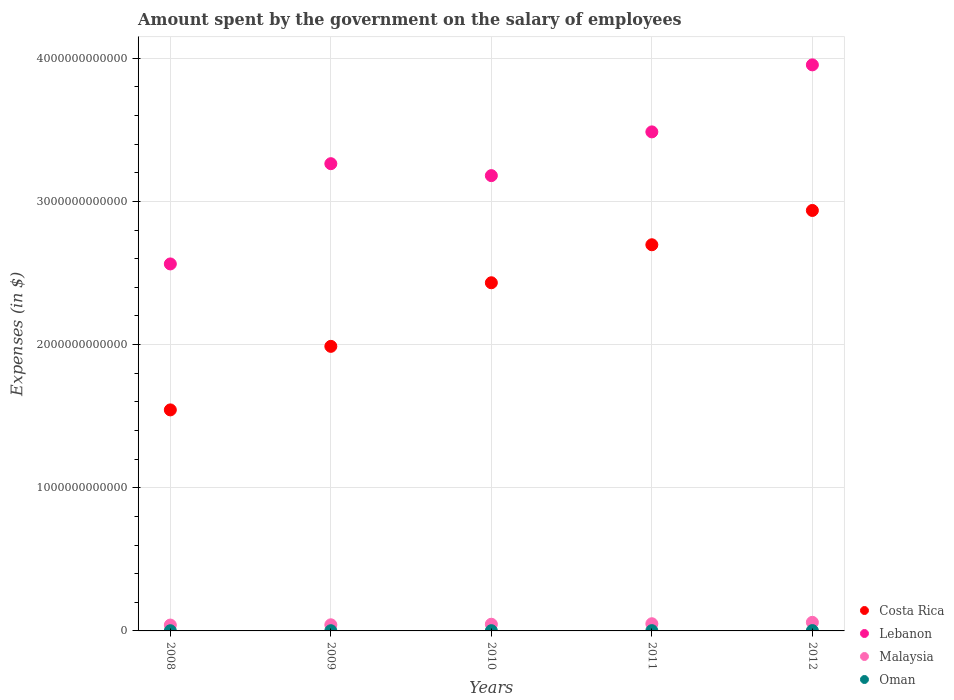How many different coloured dotlines are there?
Provide a succinct answer. 4. Is the number of dotlines equal to the number of legend labels?
Offer a terse response. Yes. What is the amount spent on the salary of employees by the government in Oman in 2009?
Offer a terse response. 1.51e+09. Across all years, what is the maximum amount spent on the salary of employees by the government in Costa Rica?
Give a very brief answer. 2.94e+12. Across all years, what is the minimum amount spent on the salary of employees by the government in Costa Rica?
Keep it short and to the point. 1.54e+12. What is the total amount spent on the salary of employees by the government in Costa Rica in the graph?
Give a very brief answer. 1.16e+13. What is the difference between the amount spent on the salary of employees by the government in Malaysia in 2008 and that in 2012?
Offer a terse response. -1.90e+1. What is the difference between the amount spent on the salary of employees by the government in Malaysia in 2008 and the amount spent on the salary of employees by the government in Oman in 2012?
Your answer should be compact. 3.87e+1. What is the average amount spent on the salary of employees by the government in Costa Rica per year?
Your answer should be compact. 2.32e+12. In the year 2010, what is the difference between the amount spent on the salary of employees by the government in Costa Rica and amount spent on the salary of employees by the government in Oman?
Ensure brevity in your answer.  2.43e+12. In how many years, is the amount spent on the salary of employees by the government in Lebanon greater than 1600000000000 $?
Ensure brevity in your answer.  5. What is the ratio of the amount spent on the salary of employees by the government in Oman in 2009 to that in 2010?
Provide a succinct answer. 0.87. What is the difference between the highest and the second highest amount spent on the salary of employees by the government in Malaysia?
Make the answer very short. 9.87e+09. What is the difference between the highest and the lowest amount spent on the salary of employees by the government in Costa Rica?
Your response must be concise. 1.39e+12. Is the sum of the amount spent on the salary of employees by the government in Malaysia in 2011 and 2012 greater than the maximum amount spent on the salary of employees by the government in Oman across all years?
Ensure brevity in your answer.  Yes. Is it the case that in every year, the sum of the amount spent on the salary of employees by the government in Oman and amount spent on the salary of employees by the government in Lebanon  is greater than the sum of amount spent on the salary of employees by the government in Costa Rica and amount spent on the salary of employees by the government in Malaysia?
Provide a succinct answer. Yes. Does the amount spent on the salary of employees by the government in Lebanon monotonically increase over the years?
Offer a terse response. No. Is the amount spent on the salary of employees by the government in Lebanon strictly greater than the amount spent on the salary of employees by the government in Costa Rica over the years?
Offer a very short reply. Yes. Is the amount spent on the salary of employees by the government in Costa Rica strictly less than the amount spent on the salary of employees by the government in Malaysia over the years?
Give a very brief answer. No. How many dotlines are there?
Your answer should be compact. 4. How many years are there in the graph?
Ensure brevity in your answer.  5. What is the difference between two consecutive major ticks on the Y-axis?
Your answer should be very brief. 1.00e+12. Does the graph contain grids?
Offer a very short reply. Yes. Where does the legend appear in the graph?
Your response must be concise. Bottom right. How many legend labels are there?
Provide a short and direct response. 4. How are the legend labels stacked?
Provide a succinct answer. Vertical. What is the title of the graph?
Offer a very short reply. Amount spent by the government on the salary of employees. Does "Tunisia" appear as one of the legend labels in the graph?
Provide a succinct answer. No. What is the label or title of the X-axis?
Give a very brief answer. Years. What is the label or title of the Y-axis?
Keep it short and to the point. Expenses (in $). What is the Expenses (in $) of Costa Rica in 2008?
Offer a terse response. 1.54e+12. What is the Expenses (in $) of Lebanon in 2008?
Offer a very short reply. 2.56e+12. What is the Expenses (in $) in Malaysia in 2008?
Your response must be concise. 4.10e+1. What is the Expenses (in $) in Oman in 2008?
Provide a succinct answer. 1.37e+09. What is the Expenses (in $) in Costa Rica in 2009?
Your answer should be compact. 1.99e+12. What is the Expenses (in $) of Lebanon in 2009?
Keep it short and to the point. 3.26e+12. What is the Expenses (in $) in Malaysia in 2009?
Your answer should be very brief. 4.28e+1. What is the Expenses (in $) in Oman in 2009?
Keep it short and to the point. 1.51e+09. What is the Expenses (in $) of Costa Rica in 2010?
Make the answer very short. 2.43e+12. What is the Expenses (in $) of Lebanon in 2010?
Ensure brevity in your answer.  3.18e+12. What is the Expenses (in $) of Malaysia in 2010?
Ensure brevity in your answer.  4.67e+1. What is the Expenses (in $) in Oman in 2010?
Ensure brevity in your answer.  1.72e+09. What is the Expenses (in $) of Costa Rica in 2011?
Provide a succinct answer. 2.70e+12. What is the Expenses (in $) of Lebanon in 2011?
Give a very brief answer. 3.49e+12. What is the Expenses (in $) of Malaysia in 2011?
Give a very brief answer. 5.01e+1. What is the Expenses (in $) in Oman in 2011?
Offer a very short reply. 1.94e+09. What is the Expenses (in $) in Costa Rica in 2012?
Provide a succinct answer. 2.94e+12. What is the Expenses (in $) of Lebanon in 2012?
Make the answer very short. 3.95e+12. What is the Expenses (in $) in Malaysia in 2012?
Your response must be concise. 6.00e+1. What is the Expenses (in $) of Oman in 2012?
Offer a very short reply. 2.31e+09. Across all years, what is the maximum Expenses (in $) of Costa Rica?
Give a very brief answer. 2.94e+12. Across all years, what is the maximum Expenses (in $) of Lebanon?
Offer a very short reply. 3.95e+12. Across all years, what is the maximum Expenses (in $) of Malaysia?
Provide a short and direct response. 6.00e+1. Across all years, what is the maximum Expenses (in $) of Oman?
Your answer should be compact. 2.31e+09. Across all years, what is the minimum Expenses (in $) of Costa Rica?
Provide a succinct answer. 1.54e+12. Across all years, what is the minimum Expenses (in $) of Lebanon?
Offer a terse response. 2.56e+12. Across all years, what is the minimum Expenses (in $) in Malaysia?
Your answer should be compact. 4.10e+1. Across all years, what is the minimum Expenses (in $) of Oman?
Your response must be concise. 1.37e+09. What is the total Expenses (in $) of Costa Rica in the graph?
Offer a terse response. 1.16e+13. What is the total Expenses (in $) in Lebanon in the graph?
Keep it short and to the point. 1.64e+13. What is the total Expenses (in $) of Malaysia in the graph?
Provide a succinct answer. 2.41e+11. What is the total Expenses (in $) of Oman in the graph?
Keep it short and to the point. 8.84e+09. What is the difference between the Expenses (in $) in Costa Rica in 2008 and that in 2009?
Your answer should be very brief. -4.44e+11. What is the difference between the Expenses (in $) of Lebanon in 2008 and that in 2009?
Your answer should be compact. -7.00e+11. What is the difference between the Expenses (in $) of Malaysia in 2008 and that in 2009?
Your answer should be very brief. -1.77e+09. What is the difference between the Expenses (in $) in Oman in 2008 and that in 2009?
Offer a terse response. -1.37e+08. What is the difference between the Expenses (in $) of Costa Rica in 2008 and that in 2010?
Offer a very short reply. -8.88e+11. What is the difference between the Expenses (in $) of Lebanon in 2008 and that in 2010?
Offer a terse response. -6.17e+11. What is the difference between the Expenses (in $) of Malaysia in 2008 and that in 2010?
Give a very brief answer. -5.65e+09. What is the difference between the Expenses (in $) in Oman in 2008 and that in 2010?
Make the answer very short. -3.54e+08. What is the difference between the Expenses (in $) in Costa Rica in 2008 and that in 2011?
Offer a terse response. -1.15e+12. What is the difference between the Expenses (in $) of Lebanon in 2008 and that in 2011?
Provide a short and direct response. -9.22e+11. What is the difference between the Expenses (in $) in Malaysia in 2008 and that in 2011?
Ensure brevity in your answer.  -9.14e+09. What is the difference between the Expenses (in $) of Oman in 2008 and that in 2011?
Provide a succinct answer. -5.66e+08. What is the difference between the Expenses (in $) in Costa Rica in 2008 and that in 2012?
Provide a succinct answer. -1.39e+12. What is the difference between the Expenses (in $) in Lebanon in 2008 and that in 2012?
Offer a terse response. -1.39e+12. What is the difference between the Expenses (in $) in Malaysia in 2008 and that in 2012?
Provide a short and direct response. -1.90e+1. What is the difference between the Expenses (in $) of Oman in 2008 and that in 2012?
Your answer should be compact. -9.38e+08. What is the difference between the Expenses (in $) of Costa Rica in 2009 and that in 2010?
Keep it short and to the point. -4.44e+11. What is the difference between the Expenses (in $) of Lebanon in 2009 and that in 2010?
Provide a short and direct response. 8.34e+1. What is the difference between the Expenses (in $) of Malaysia in 2009 and that in 2010?
Ensure brevity in your answer.  -3.88e+09. What is the difference between the Expenses (in $) in Oman in 2009 and that in 2010?
Give a very brief answer. -2.16e+08. What is the difference between the Expenses (in $) of Costa Rica in 2009 and that in 2011?
Offer a terse response. -7.10e+11. What is the difference between the Expenses (in $) of Lebanon in 2009 and that in 2011?
Keep it short and to the point. -2.22e+11. What is the difference between the Expenses (in $) of Malaysia in 2009 and that in 2011?
Your response must be concise. -7.37e+09. What is the difference between the Expenses (in $) in Oman in 2009 and that in 2011?
Offer a terse response. -4.29e+08. What is the difference between the Expenses (in $) in Costa Rica in 2009 and that in 2012?
Give a very brief answer. -9.49e+11. What is the difference between the Expenses (in $) in Lebanon in 2009 and that in 2012?
Provide a succinct answer. -6.90e+11. What is the difference between the Expenses (in $) in Malaysia in 2009 and that in 2012?
Offer a terse response. -1.72e+1. What is the difference between the Expenses (in $) of Oman in 2009 and that in 2012?
Make the answer very short. -8.01e+08. What is the difference between the Expenses (in $) of Costa Rica in 2010 and that in 2011?
Provide a succinct answer. -2.65e+11. What is the difference between the Expenses (in $) of Lebanon in 2010 and that in 2011?
Give a very brief answer. -3.06e+11. What is the difference between the Expenses (in $) of Malaysia in 2010 and that in 2011?
Your answer should be compact. -3.49e+09. What is the difference between the Expenses (in $) in Oman in 2010 and that in 2011?
Make the answer very short. -2.13e+08. What is the difference between the Expenses (in $) of Costa Rica in 2010 and that in 2012?
Offer a terse response. -5.05e+11. What is the difference between the Expenses (in $) in Lebanon in 2010 and that in 2012?
Provide a succinct answer. -7.74e+11. What is the difference between the Expenses (in $) of Malaysia in 2010 and that in 2012?
Your answer should be very brief. -1.34e+1. What is the difference between the Expenses (in $) in Oman in 2010 and that in 2012?
Offer a terse response. -5.85e+08. What is the difference between the Expenses (in $) in Costa Rica in 2011 and that in 2012?
Keep it short and to the point. -2.40e+11. What is the difference between the Expenses (in $) of Lebanon in 2011 and that in 2012?
Make the answer very short. -4.68e+11. What is the difference between the Expenses (in $) of Malaysia in 2011 and that in 2012?
Make the answer very short. -9.87e+09. What is the difference between the Expenses (in $) of Oman in 2011 and that in 2012?
Keep it short and to the point. -3.72e+08. What is the difference between the Expenses (in $) of Costa Rica in 2008 and the Expenses (in $) of Lebanon in 2009?
Offer a terse response. -1.72e+12. What is the difference between the Expenses (in $) in Costa Rica in 2008 and the Expenses (in $) in Malaysia in 2009?
Provide a succinct answer. 1.50e+12. What is the difference between the Expenses (in $) in Costa Rica in 2008 and the Expenses (in $) in Oman in 2009?
Offer a very short reply. 1.54e+12. What is the difference between the Expenses (in $) of Lebanon in 2008 and the Expenses (in $) of Malaysia in 2009?
Your response must be concise. 2.52e+12. What is the difference between the Expenses (in $) in Lebanon in 2008 and the Expenses (in $) in Oman in 2009?
Give a very brief answer. 2.56e+12. What is the difference between the Expenses (in $) of Malaysia in 2008 and the Expenses (in $) of Oman in 2009?
Provide a succinct answer. 3.95e+1. What is the difference between the Expenses (in $) of Costa Rica in 2008 and the Expenses (in $) of Lebanon in 2010?
Your answer should be compact. -1.64e+12. What is the difference between the Expenses (in $) of Costa Rica in 2008 and the Expenses (in $) of Malaysia in 2010?
Keep it short and to the point. 1.50e+12. What is the difference between the Expenses (in $) of Costa Rica in 2008 and the Expenses (in $) of Oman in 2010?
Offer a very short reply. 1.54e+12. What is the difference between the Expenses (in $) in Lebanon in 2008 and the Expenses (in $) in Malaysia in 2010?
Give a very brief answer. 2.52e+12. What is the difference between the Expenses (in $) in Lebanon in 2008 and the Expenses (in $) in Oman in 2010?
Keep it short and to the point. 2.56e+12. What is the difference between the Expenses (in $) in Malaysia in 2008 and the Expenses (in $) in Oman in 2010?
Make the answer very short. 3.93e+1. What is the difference between the Expenses (in $) in Costa Rica in 2008 and the Expenses (in $) in Lebanon in 2011?
Give a very brief answer. -1.94e+12. What is the difference between the Expenses (in $) in Costa Rica in 2008 and the Expenses (in $) in Malaysia in 2011?
Provide a succinct answer. 1.49e+12. What is the difference between the Expenses (in $) in Costa Rica in 2008 and the Expenses (in $) in Oman in 2011?
Offer a very short reply. 1.54e+12. What is the difference between the Expenses (in $) in Lebanon in 2008 and the Expenses (in $) in Malaysia in 2011?
Offer a terse response. 2.51e+12. What is the difference between the Expenses (in $) in Lebanon in 2008 and the Expenses (in $) in Oman in 2011?
Your answer should be compact. 2.56e+12. What is the difference between the Expenses (in $) in Malaysia in 2008 and the Expenses (in $) in Oman in 2011?
Provide a succinct answer. 3.91e+1. What is the difference between the Expenses (in $) in Costa Rica in 2008 and the Expenses (in $) in Lebanon in 2012?
Your answer should be very brief. -2.41e+12. What is the difference between the Expenses (in $) in Costa Rica in 2008 and the Expenses (in $) in Malaysia in 2012?
Your response must be concise. 1.48e+12. What is the difference between the Expenses (in $) in Costa Rica in 2008 and the Expenses (in $) in Oman in 2012?
Make the answer very short. 1.54e+12. What is the difference between the Expenses (in $) of Lebanon in 2008 and the Expenses (in $) of Malaysia in 2012?
Make the answer very short. 2.50e+12. What is the difference between the Expenses (in $) of Lebanon in 2008 and the Expenses (in $) of Oman in 2012?
Offer a very short reply. 2.56e+12. What is the difference between the Expenses (in $) in Malaysia in 2008 and the Expenses (in $) in Oman in 2012?
Your answer should be compact. 3.87e+1. What is the difference between the Expenses (in $) in Costa Rica in 2009 and the Expenses (in $) in Lebanon in 2010?
Offer a terse response. -1.19e+12. What is the difference between the Expenses (in $) in Costa Rica in 2009 and the Expenses (in $) in Malaysia in 2010?
Your response must be concise. 1.94e+12. What is the difference between the Expenses (in $) in Costa Rica in 2009 and the Expenses (in $) in Oman in 2010?
Your response must be concise. 1.99e+12. What is the difference between the Expenses (in $) in Lebanon in 2009 and the Expenses (in $) in Malaysia in 2010?
Offer a very short reply. 3.22e+12. What is the difference between the Expenses (in $) in Lebanon in 2009 and the Expenses (in $) in Oman in 2010?
Offer a very short reply. 3.26e+12. What is the difference between the Expenses (in $) of Malaysia in 2009 and the Expenses (in $) of Oman in 2010?
Offer a terse response. 4.11e+1. What is the difference between the Expenses (in $) of Costa Rica in 2009 and the Expenses (in $) of Lebanon in 2011?
Give a very brief answer. -1.50e+12. What is the difference between the Expenses (in $) of Costa Rica in 2009 and the Expenses (in $) of Malaysia in 2011?
Your response must be concise. 1.94e+12. What is the difference between the Expenses (in $) in Costa Rica in 2009 and the Expenses (in $) in Oman in 2011?
Make the answer very short. 1.99e+12. What is the difference between the Expenses (in $) in Lebanon in 2009 and the Expenses (in $) in Malaysia in 2011?
Your answer should be very brief. 3.21e+12. What is the difference between the Expenses (in $) of Lebanon in 2009 and the Expenses (in $) of Oman in 2011?
Your response must be concise. 3.26e+12. What is the difference between the Expenses (in $) of Malaysia in 2009 and the Expenses (in $) of Oman in 2011?
Keep it short and to the point. 4.08e+1. What is the difference between the Expenses (in $) of Costa Rica in 2009 and the Expenses (in $) of Lebanon in 2012?
Offer a very short reply. -1.97e+12. What is the difference between the Expenses (in $) of Costa Rica in 2009 and the Expenses (in $) of Malaysia in 2012?
Make the answer very short. 1.93e+12. What is the difference between the Expenses (in $) of Costa Rica in 2009 and the Expenses (in $) of Oman in 2012?
Offer a terse response. 1.99e+12. What is the difference between the Expenses (in $) of Lebanon in 2009 and the Expenses (in $) of Malaysia in 2012?
Your answer should be very brief. 3.20e+12. What is the difference between the Expenses (in $) in Lebanon in 2009 and the Expenses (in $) in Oman in 2012?
Your answer should be compact. 3.26e+12. What is the difference between the Expenses (in $) in Malaysia in 2009 and the Expenses (in $) in Oman in 2012?
Ensure brevity in your answer.  4.05e+1. What is the difference between the Expenses (in $) of Costa Rica in 2010 and the Expenses (in $) of Lebanon in 2011?
Offer a very short reply. -1.05e+12. What is the difference between the Expenses (in $) in Costa Rica in 2010 and the Expenses (in $) in Malaysia in 2011?
Your answer should be compact. 2.38e+12. What is the difference between the Expenses (in $) of Costa Rica in 2010 and the Expenses (in $) of Oman in 2011?
Give a very brief answer. 2.43e+12. What is the difference between the Expenses (in $) of Lebanon in 2010 and the Expenses (in $) of Malaysia in 2011?
Offer a terse response. 3.13e+12. What is the difference between the Expenses (in $) of Lebanon in 2010 and the Expenses (in $) of Oman in 2011?
Offer a terse response. 3.18e+12. What is the difference between the Expenses (in $) in Malaysia in 2010 and the Expenses (in $) in Oman in 2011?
Make the answer very short. 4.47e+1. What is the difference between the Expenses (in $) in Costa Rica in 2010 and the Expenses (in $) in Lebanon in 2012?
Give a very brief answer. -1.52e+12. What is the difference between the Expenses (in $) in Costa Rica in 2010 and the Expenses (in $) in Malaysia in 2012?
Provide a short and direct response. 2.37e+12. What is the difference between the Expenses (in $) of Costa Rica in 2010 and the Expenses (in $) of Oman in 2012?
Your answer should be very brief. 2.43e+12. What is the difference between the Expenses (in $) in Lebanon in 2010 and the Expenses (in $) in Malaysia in 2012?
Provide a short and direct response. 3.12e+12. What is the difference between the Expenses (in $) of Lebanon in 2010 and the Expenses (in $) of Oman in 2012?
Ensure brevity in your answer.  3.18e+12. What is the difference between the Expenses (in $) of Malaysia in 2010 and the Expenses (in $) of Oman in 2012?
Ensure brevity in your answer.  4.44e+1. What is the difference between the Expenses (in $) of Costa Rica in 2011 and the Expenses (in $) of Lebanon in 2012?
Ensure brevity in your answer.  -1.26e+12. What is the difference between the Expenses (in $) of Costa Rica in 2011 and the Expenses (in $) of Malaysia in 2012?
Your answer should be compact. 2.64e+12. What is the difference between the Expenses (in $) of Costa Rica in 2011 and the Expenses (in $) of Oman in 2012?
Your answer should be very brief. 2.70e+12. What is the difference between the Expenses (in $) in Lebanon in 2011 and the Expenses (in $) in Malaysia in 2012?
Make the answer very short. 3.43e+12. What is the difference between the Expenses (in $) of Lebanon in 2011 and the Expenses (in $) of Oman in 2012?
Keep it short and to the point. 3.48e+12. What is the difference between the Expenses (in $) in Malaysia in 2011 and the Expenses (in $) in Oman in 2012?
Your response must be concise. 4.78e+1. What is the average Expenses (in $) of Costa Rica per year?
Your answer should be compact. 2.32e+12. What is the average Expenses (in $) in Lebanon per year?
Your answer should be compact. 3.29e+12. What is the average Expenses (in $) in Malaysia per year?
Make the answer very short. 4.81e+1. What is the average Expenses (in $) of Oman per year?
Give a very brief answer. 1.77e+09. In the year 2008, what is the difference between the Expenses (in $) in Costa Rica and Expenses (in $) in Lebanon?
Make the answer very short. -1.02e+12. In the year 2008, what is the difference between the Expenses (in $) in Costa Rica and Expenses (in $) in Malaysia?
Give a very brief answer. 1.50e+12. In the year 2008, what is the difference between the Expenses (in $) of Costa Rica and Expenses (in $) of Oman?
Provide a short and direct response. 1.54e+12. In the year 2008, what is the difference between the Expenses (in $) in Lebanon and Expenses (in $) in Malaysia?
Offer a very short reply. 2.52e+12. In the year 2008, what is the difference between the Expenses (in $) in Lebanon and Expenses (in $) in Oman?
Provide a succinct answer. 2.56e+12. In the year 2008, what is the difference between the Expenses (in $) of Malaysia and Expenses (in $) of Oman?
Provide a short and direct response. 3.96e+1. In the year 2009, what is the difference between the Expenses (in $) in Costa Rica and Expenses (in $) in Lebanon?
Offer a very short reply. -1.28e+12. In the year 2009, what is the difference between the Expenses (in $) of Costa Rica and Expenses (in $) of Malaysia?
Provide a succinct answer. 1.95e+12. In the year 2009, what is the difference between the Expenses (in $) of Costa Rica and Expenses (in $) of Oman?
Make the answer very short. 1.99e+12. In the year 2009, what is the difference between the Expenses (in $) of Lebanon and Expenses (in $) of Malaysia?
Offer a terse response. 3.22e+12. In the year 2009, what is the difference between the Expenses (in $) in Lebanon and Expenses (in $) in Oman?
Your answer should be compact. 3.26e+12. In the year 2009, what is the difference between the Expenses (in $) in Malaysia and Expenses (in $) in Oman?
Give a very brief answer. 4.13e+1. In the year 2010, what is the difference between the Expenses (in $) of Costa Rica and Expenses (in $) of Lebanon?
Give a very brief answer. -7.48e+11. In the year 2010, what is the difference between the Expenses (in $) of Costa Rica and Expenses (in $) of Malaysia?
Provide a succinct answer. 2.39e+12. In the year 2010, what is the difference between the Expenses (in $) of Costa Rica and Expenses (in $) of Oman?
Your response must be concise. 2.43e+12. In the year 2010, what is the difference between the Expenses (in $) of Lebanon and Expenses (in $) of Malaysia?
Give a very brief answer. 3.13e+12. In the year 2010, what is the difference between the Expenses (in $) of Lebanon and Expenses (in $) of Oman?
Offer a very short reply. 3.18e+12. In the year 2010, what is the difference between the Expenses (in $) of Malaysia and Expenses (in $) of Oman?
Ensure brevity in your answer.  4.49e+1. In the year 2011, what is the difference between the Expenses (in $) of Costa Rica and Expenses (in $) of Lebanon?
Keep it short and to the point. -7.88e+11. In the year 2011, what is the difference between the Expenses (in $) of Costa Rica and Expenses (in $) of Malaysia?
Your answer should be compact. 2.65e+12. In the year 2011, what is the difference between the Expenses (in $) in Costa Rica and Expenses (in $) in Oman?
Your answer should be very brief. 2.70e+12. In the year 2011, what is the difference between the Expenses (in $) in Lebanon and Expenses (in $) in Malaysia?
Keep it short and to the point. 3.44e+12. In the year 2011, what is the difference between the Expenses (in $) of Lebanon and Expenses (in $) of Oman?
Offer a terse response. 3.48e+12. In the year 2011, what is the difference between the Expenses (in $) in Malaysia and Expenses (in $) in Oman?
Your answer should be very brief. 4.82e+1. In the year 2012, what is the difference between the Expenses (in $) of Costa Rica and Expenses (in $) of Lebanon?
Give a very brief answer. -1.02e+12. In the year 2012, what is the difference between the Expenses (in $) in Costa Rica and Expenses (in $) in Malaysia?
Provide a short and direct response. 2.88e+12. In the year 2012, what is the difference between the Expenses (in $) in Costa Rica and Expenses (in $) in Oman?
Make the answer very short. 2.93e+12. In the year 2012, what is the difference between the Expenses (in $) in Lebanon and Expenses (in $) in Malaysia?
Keep it short and to the point. 3.89e+12. In the year 2012, what is the difference between the Expenses (in $) of Lebanon and Expenses (in $) of Oman?
Offer a terse response. 3.95e+12. In the year 2012, what is the difference between the Expenses (in $) in Malaysia and Expenses (in $) in Oman?
Give a very brief answer. 5.77e+1. What is the ratio of the Expenses (in $) of Costa Rica in 2008 to that in 2009?
Your answer should be compact. 0.78. What is the ratio of the Expenses (in $) of Lebanon in 2008 to that in 2009?
Provide a short and direct response. 0.79. What is the ratio of the Expenses (in $) in Malaysia in 2008 to that in 2009?
Offer a very short reply. 0.96. What is the ratio of the Expenses (in $) in Oman in 2008 to that in 2009?
Your answer should be very brief. 0.91. What is the ratio of the Expenses (in $) in Costa Rica in 2008 to that in 2010?
Your response must be concise. 0.63. What is the ratio of the Expenses (in $) in Lebanon in 2008 to that in 2010?
Your response must be concise. 0.81. What is the ratio of the Expenses (in $) in Malaysia in 2008 to that in 2010?
Offer a terse response. 0.88. What is the ratio of the Expenses (in $) of Oman in 2008 to that in 2010?
Provide a short and direct response. 0.79. What is the ratio of the Expenses (in $) of Costa Rica in 2008 to that in 2011?
Provide a short and direct response. 0.57. What is the ratio of the Expenses (in $) of Lebanon in 2008 to that in 2011?
Give a very brief answer. 0.74. What is the ratio of the Expenses (in $) of Malaysia in 2008 to that in 2011?
Keep it short and to the point. 0.82. What is the ratio of the Expenses (in $) of Oman in 2008 to that in 2011?
Ensure brevity in your answer.  0.71. What is the ratio of the Expenses (in $) in Costa Rica in 2008 to that in 2012?
Provide a succinct answer. 0.53. What is the ratio of the Expenses (in $) of Lebanon in 2008 to that in 2012?
Provide a succinct answer. 0.65. What is the ratio of the Expenses (in $) in Malaysia in 2008 to that in 2012?
Offer a very short reply. 0.68. What is the ratio of the Expenses (in $) of Oman in 2008 to that in 2012?
Your response must be concise. 0.59. What is the ratio of the Expenses (in $) of Costa Rica in 2009 to that in 2010?
Offer a very short reply. 0.82. What is the ratio of the Expenses (in $) in Lebanon in 2009 to that in 2010?
Provide a succinct answer. 1.03. What is the ratio of the Expenses (in $) of Malaysia in 2009 to that in 2010?
Offer a very short reply. 0.92. What is the ratio of the Expenses (in $) in Oman in 2009 to that in 2010?
Ensure brevity in your answer.  0.87. What is the ratio of the Expenses (in $) of Costa Rica in 2009 to that in 2011?
Your answer should be compact. 0.74. What is the ratio of the Expenses (in $) in Lebanon in 2009 to that in 2011?
Provide a short and direct response. 0.94. What is the ratio of the Expenses (in $) of Malaysia in 2009 to that in 2011?
Your answer should be very brief. 0.85. What is the ratio of the Expenses (in $) in Oman in 2009 to that in 2011?
Offer a very short reply. 0.78. What is the ratio of the Expenses (in $) of Costa Rica in 2009 to that in 2012?
Your answer should be compact. 0.68. What is the ratio of the Expenses (in $) of Lebanon in 2009 to that in 2012?
Offer a terse response. 0.83. What is the ratio of the Expenses (in $) of Malaysia in 2009 to that in 2012?
Make the answer very short. 0.71. What is the ratio of the Expenses (in $) in Oman in 2009 to that in 2012?
Offer a very short reply. 0.65. What is the ratio of the Expenses (in $) in Costa Rica in 2010 to that in 2011?
Offer a terse response. 0.9. What is the ratio of the Expenses (in $) of Lebanon in 2010 to that in 2011?
Your response must be concise. 0.91. What is the ratio of the Expenses (in $) of Malaysia in 2010 to that in 2011?
Offer a very short reply. 0.93. What is the ratio of the Expenses (in $) of Oman in 2010 to that in 2011?
Provide a succinct answer. 0.89. What is the ratio of the Expenses (in $) in Costa Rica in 2010 to that in 2012?
Provide a short and direct response. 0.83. What is the ratio of the Expenses (in $) of Lebanon in 2010 to that in 2012?
Make the answer very short. 0.8. What is the ratio of the Expenses (in $) of Malaysia in 2010 to that in 2012?
Give a very brief answer. 0.78. What is the ratio of the Expenses (in $) in Oman in 2010 to that in 2012?
Your answer should be compact. 0.75. What is the ratio of the Expenses (in $) of Costa Rica in 2011 to that in 2012?
Offer a terse response. 0.92. What is the ratio of the Expenses (in $) in Lebanon in 2011 to that in 2012?
Give a very brief answer. 0.88. What is the ratio of the Expenses (in $) of Malaysia in 2011 to that in 2012?
Provide a succinct answer. 0.84. What is the ratio of the Expenses (in $) in Oman in 2011 to that in 2012?
Keep it short and to the point. 0.84. What is the difference between the highest and the second highest Expenses (in $) of Costa Rica?
Make the answer very short. 2.40e+11. What is the difference between the highest and the second highest Expenses (in $) of Lebanon?
Ensure brevity in your answer.  4.68e+11. What is the difference between the highest and the second highest Expenses (in $) of Malaysia?
Your response must be concise. 9.87e+09. What is the difference between the highest and the second highest Expenses (in $) in Oman?
Give a very brief answer. 3.72e+08. What is the difference between the highest and the lowest Expenses (in $) of Costa Rica?
Give a very brief answer. 1.39e+12. What is the difference between the highest and the lowest Expenses (in $) in Lebanon?
Make the answer very short. 1.39e+12. What is the difference between the highest and the lowest Expenses (in $) in Malaysia?
Your response must be concise. 1.90e+1. What is the difference between the highest and the lowest Expenses (in $) of Oman?
Your answer should be very brief. 9.38e+08. 